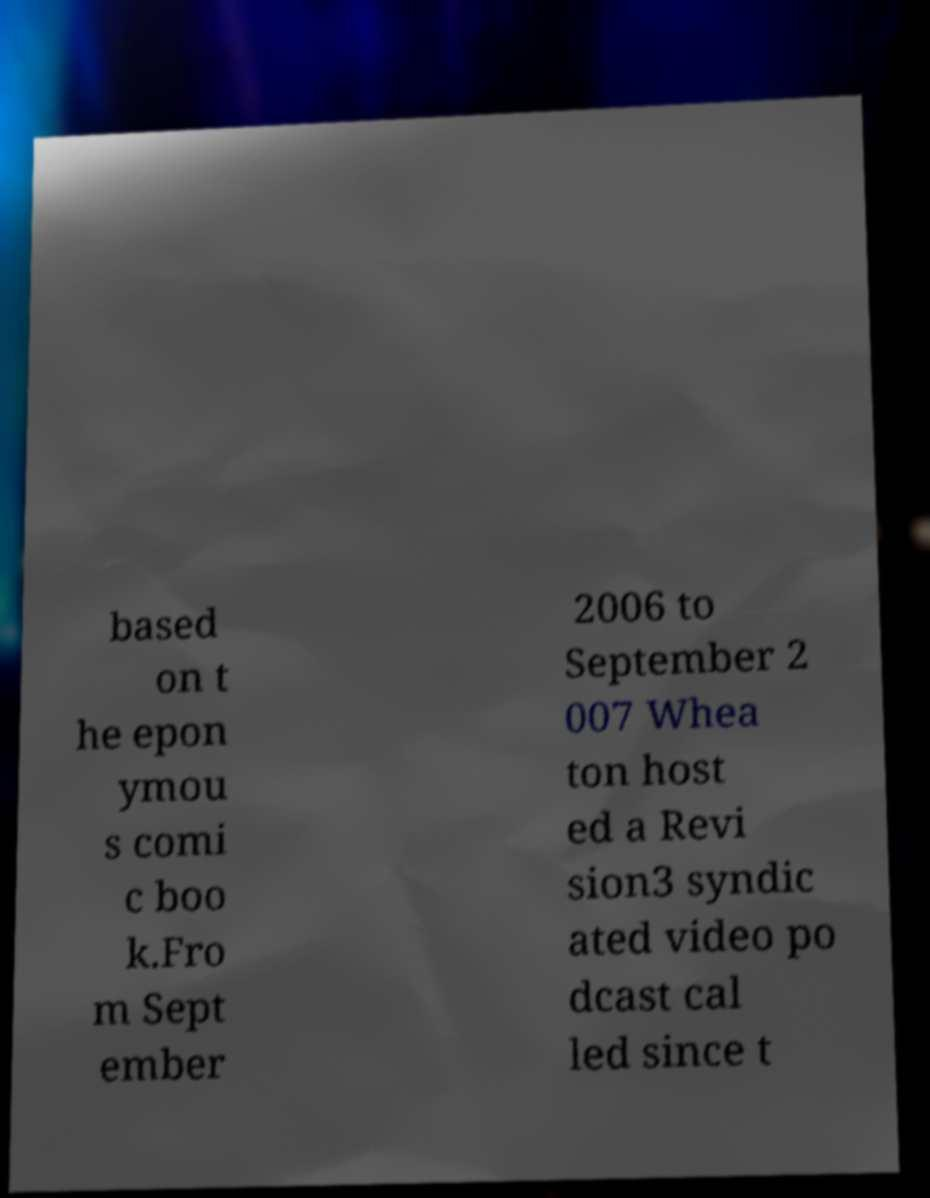For documentation purposes, I need the text within this image transcribed. Could you provide that? based on t he epon ymou s comi c boo k.Fro m Sept ember 2006 to September 2 007 Whea ton host ed a Revi sion3 syndic ated video po dcast cal led since t 